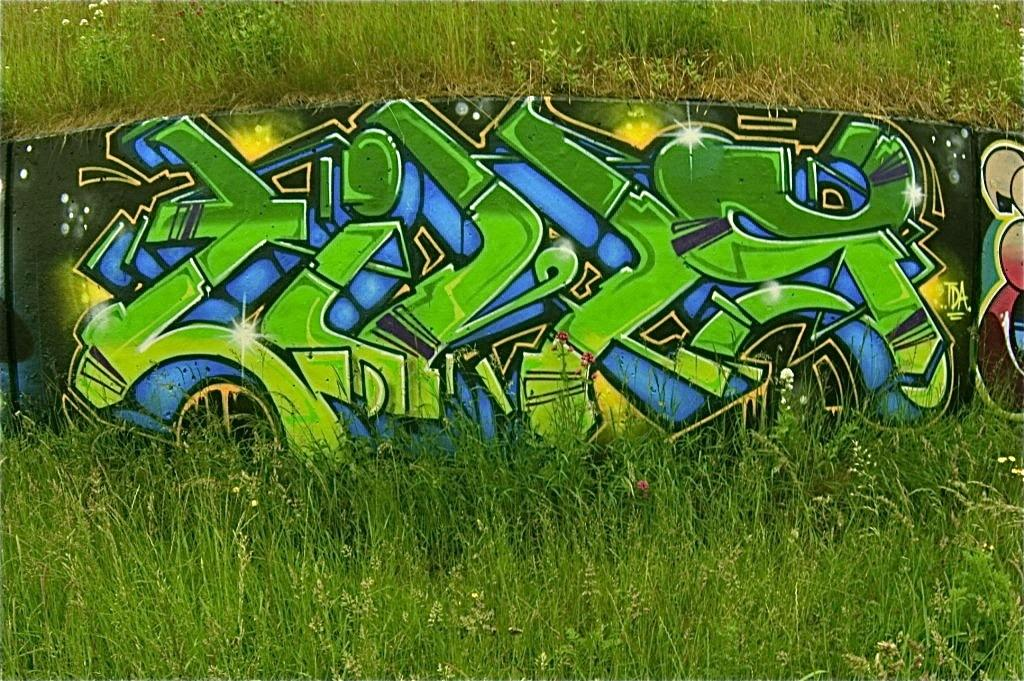What is depicted on the board in the image? There is a painting on a board in the image. What type of vegetation can be seen in the image? There is grass visible in the image. What type of creature is shown interacting with the painting on the board in the image? There is no creature present in the image; it only features a painting on a board and grass. Can you tell me how many bombs are visible in the image? There are no bombs present in the image. 